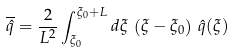Convert formula to latex. <formula><loc_0><loc_0><loc_500><loc_500>\overline { \hat { q } } = \frac { 2 } { L ^ { 2 } } \int _ { \xi _ { 0 } } ^ { \xi _ { 0 } + L } d \xi \, \left ( \xi - \xi _ { 0 } \right ) \, \hat { q } ( \xi )</formula> 